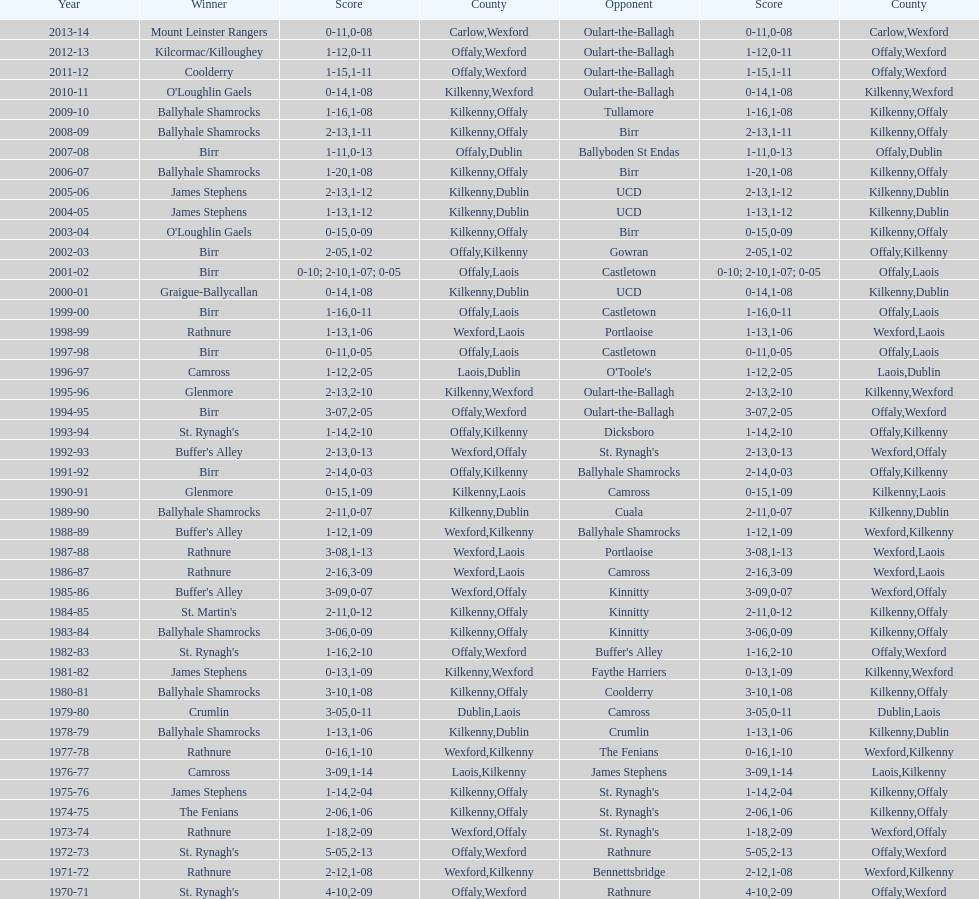For how many continuous years did rathnure achieve victory? 2. 